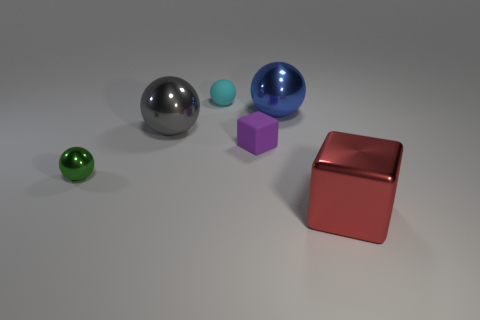What is the shape of the big shiny thing to the left of the rubber ball behind the tiny metal ball?
Provide a succinct answer. Sphere. Is the shape of the red metal object the same as the big shiny thing to the left of the cyan thing?
Ensure brevity in your answer.  No. There is another metallic sphere that is the same size as the blue sphere; what color is it?
Make the answer very short. Gray. Is the number of green shiny balls that are behind the tiny purple cube less than the number of green metal balls that are to the left of the red cube?
Ensure brevity in your answer.  Yes. What is the shape of the big red metal object right of the metal ball that is in front of the cube that is left of the large metal cube?
Offer a terse response. Cube. There is a sphere right of the cyan matte object; is it the same color as the large metallic ball that is left of the small cyan thing?
Your response must be concise. No. How many shiny things are either tiny purple cubes or large gray spheres?
Offer a very short reply. 1. There is a big thing that is left of the rubber object behind the block that is behind the large red block; what is its color?
Provide a short and direct response. Gray. What is the color of the other tiny object that is the same shape as the cyan object?
Ensure brevity in your answer.  Green. Is there any other thing that is the same color as the tiny shiny sphere?
Provide a short and direct response. No. 